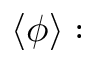Convert formula to latex. <formula><loc_0><loc_0><loc_500><loc_500>\langle \phi \rangle \colon</formula> 